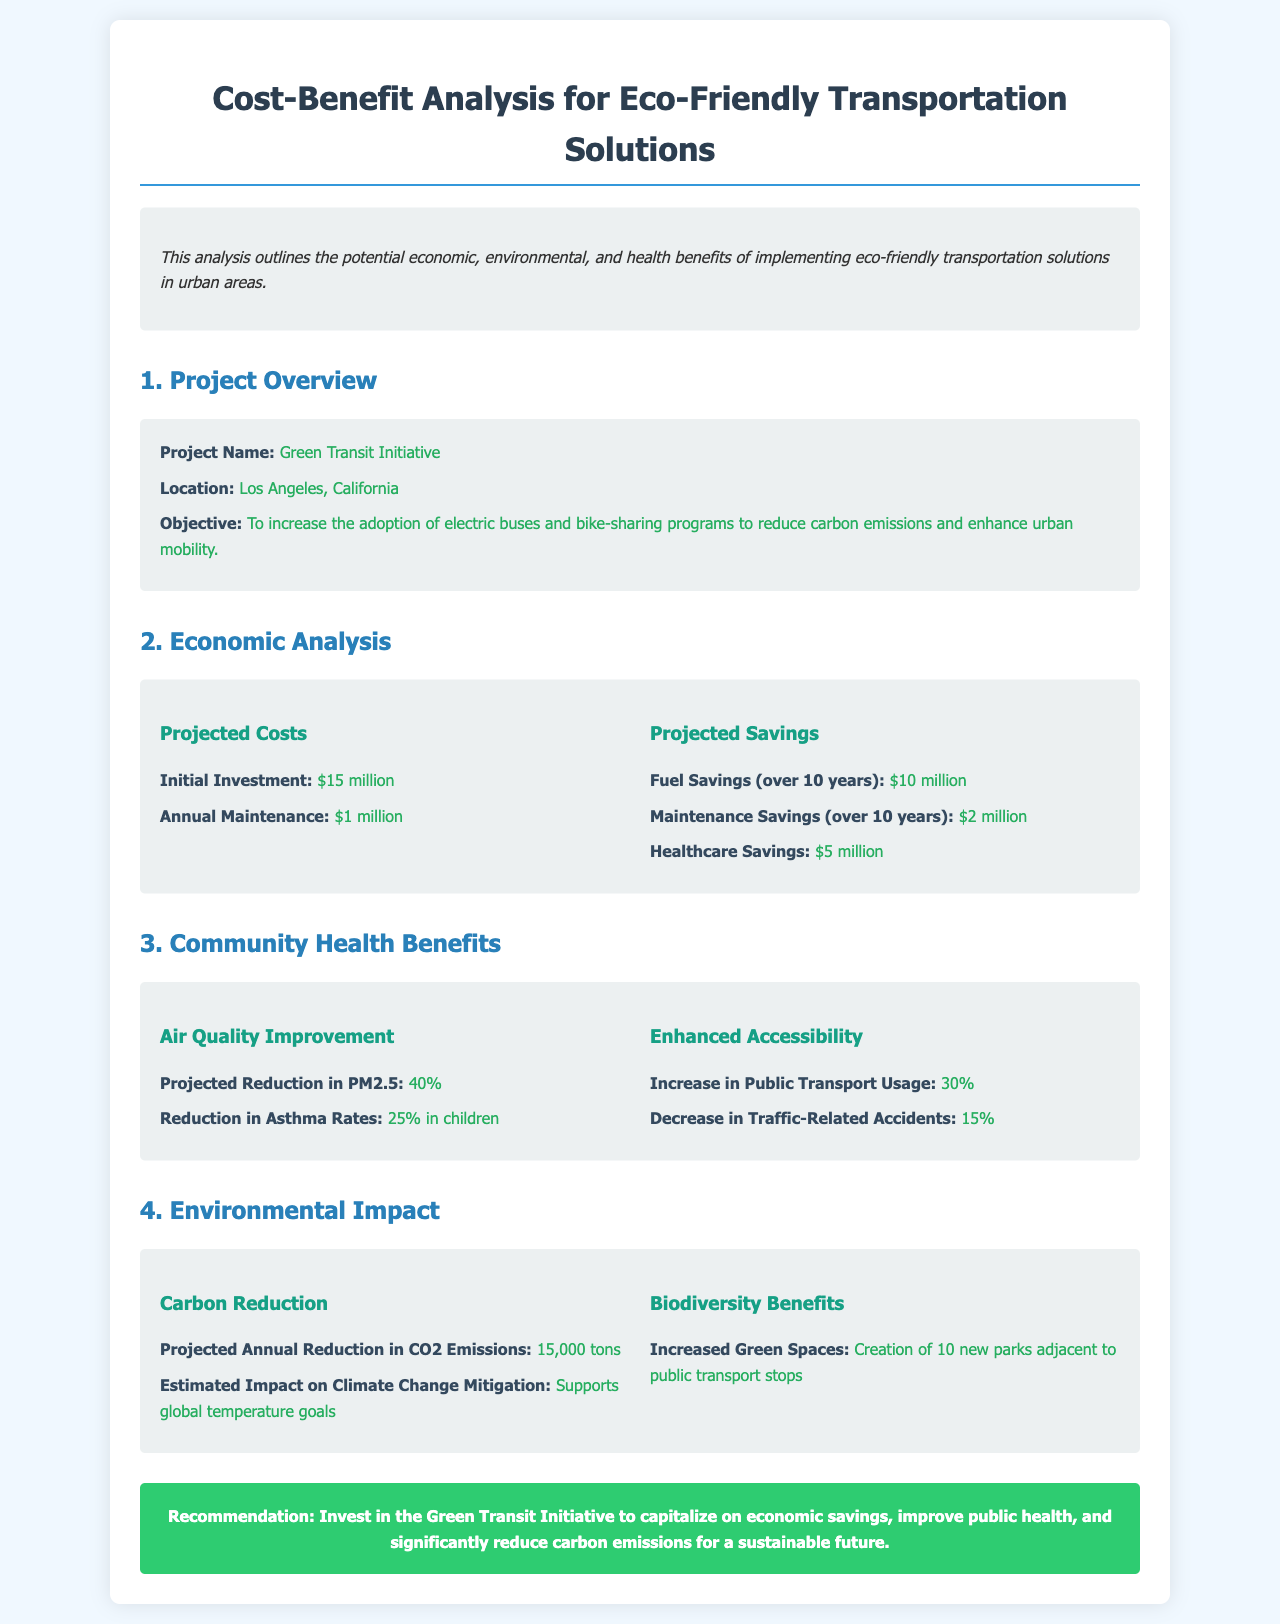What is the project name? The project name is explicitly stated in the document and is "Green Transit Initiative."
Answer: Green Transit Initiative Where is the project located? The document specifies the location of the project as "Los Angeles, California."
Answer: Los Angeles, California What is the initial investment amount? The document lists the initial investment clearly as "$15 million."
Answer: $15 million What is the projected reduction in PM2.5? The document shows the projected reduction in PM2.5 as "40%."
Answer: 40% How much are the healthcare savings projected to be? The healthcare savings are detailed in the economic analysis section, and they amount to "$5 million."
Answer: $5 million What is the projected annual reduction in CO2 emissions? The document indicates the annual reduction in CO2 emissions is "15,000 tons."
Answer: 15,000 tons What percentage increase in public transport usage is projected? The document reports a "30%" increase in public transport usage.
Answer: 30% How many new parks are projected to be created? The document notes that there will be "10 new parks" created adjacent to public transport stops.
Answer: 10 new parks What is the recommendation made in the conclusion? The conclusion recommends investing in the initiative for its various benefits as noted.
Answer: Invest in the Green Transit Initiative 